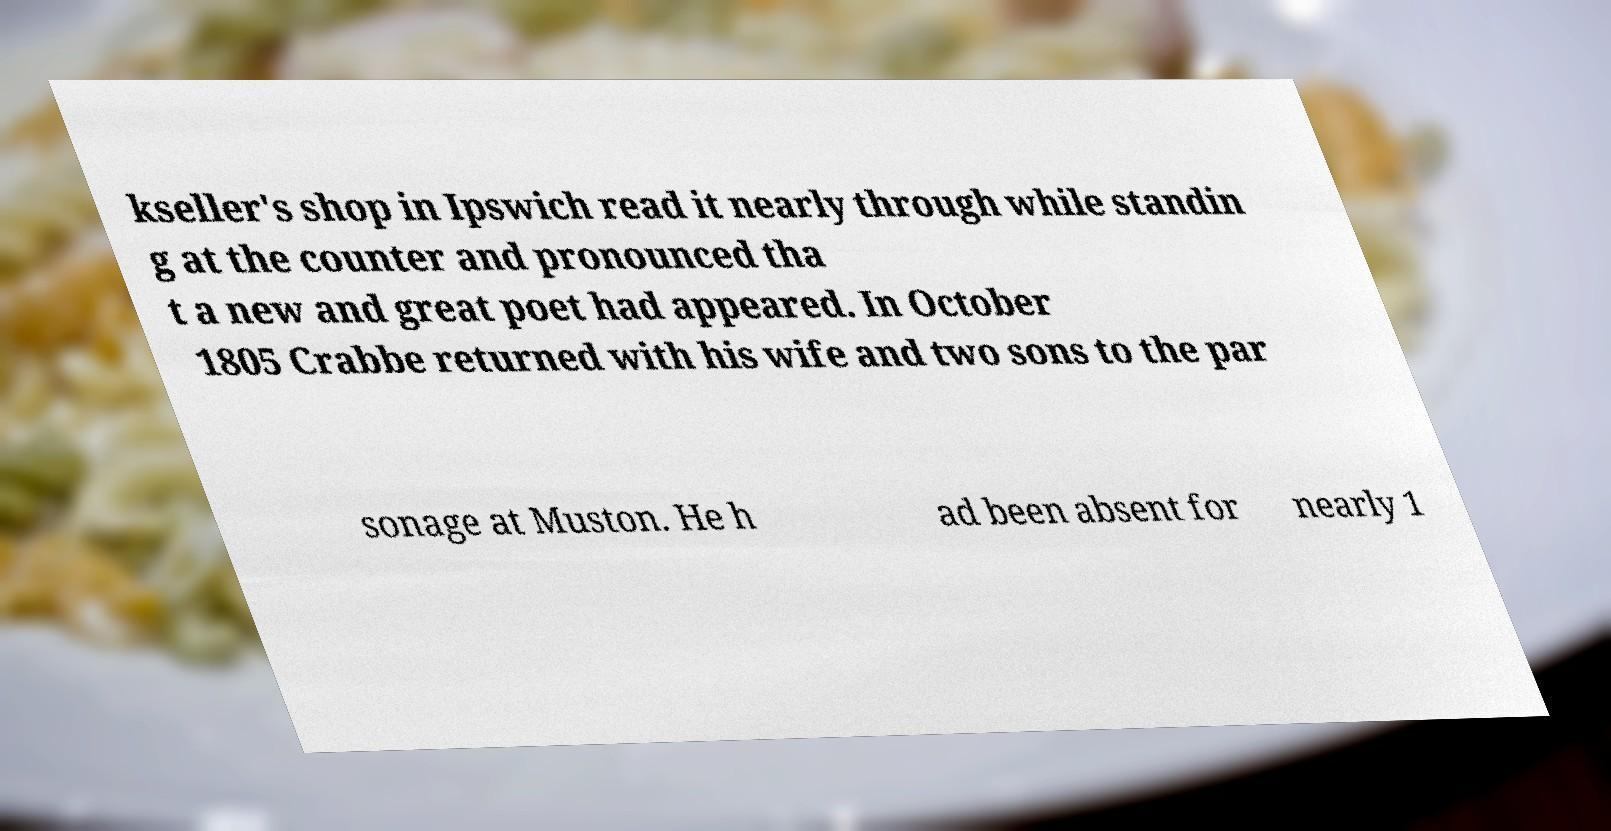There's text embedded in this image that I need extracted. Can you transcribe it verbatim? kseller's shop in Ipswich read it nearly through while standin g at the counter and pronounced tha t a new and great poet had appeared. In October 1805 Crabbe returned with his wife and two sons to the par sonage at Muston. He h ad been absent for nearly 1 